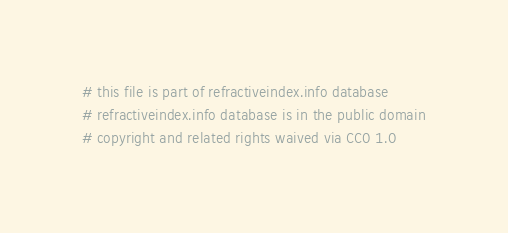<code> <loc_0><loc_0><loc_500><loc_500><_YAML_># this file is part of refractiveindex.info database
# refractiveindex.info database is in the public domain
# copyright and related rights waived via CC0 1.0
</code> 